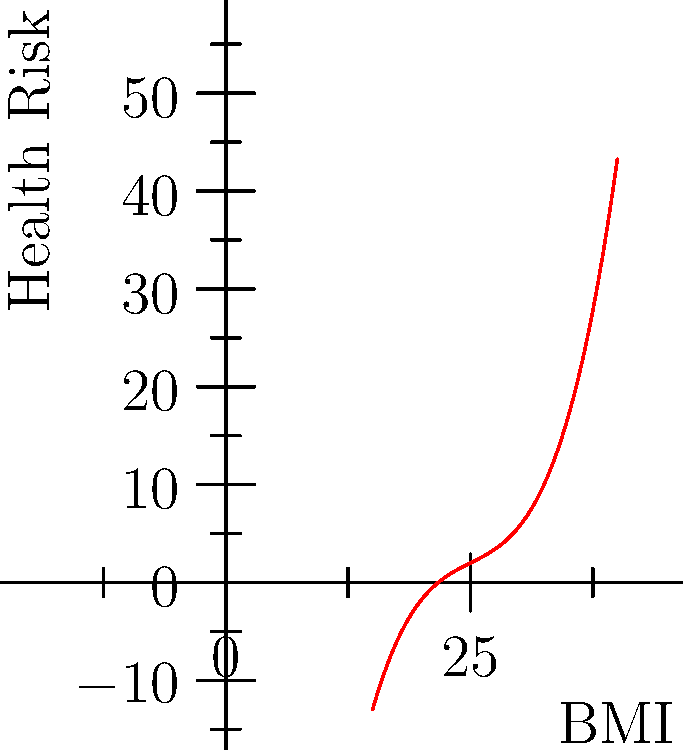The graph shows the relationship between Body Mass Index (BMI) and health risk, represented by a polynomial function. Points A, B, C, and D correspond to BMI values of 20, 25, 30, and 35, respectively. Based on this curve, which BMI range is associated with the lowest health risk, and what does this suggest about the limitations of using BMI as a sole indicator of health? To answer this question, we need to analyze the graph and interpret its implications:

1. The y-axis represents health risk, with lower values indicating lower risk.
2. The x-axis represents BMI values.
3. The curve shows how health risk changes with BMI.

Analyzing the curve:
1. The lowest point on the curve is at point B, which corresponds to a BMI of 25.
2. This indicates that a BMI of 25 is associated with the lowest health risk according to this model.
3. The curve increases on both sides of point B, showing higher health risks for both lower and higher BMI values.

Implications and limitations of BMI:
1. The U-shaped curve suggests that both underweight (BMI < 25) and overweight (BMI > 25) individuals may face increased health risks.
2. However, the curve is symmetrical around BMI 25, which doesn't accurately reflect real-world health risks. In reality, the risks associated with being underweight vs. overweight are often different.
3. The model doesn't account for factors such as muscle mass, body composition, or individual variations, which can significantly impact health regardless of BMI.
4. It doesn't consider other health indicators like blood pressure, cholesterol levels, or lifestyle factors.

In conclusion, while the graph suggests a BMI around 25 is optimal, it's crucial to recognize that BMI alone is an oversimplified measure of health. A comprehensive health assessment should include multiple factors beyond just BMI.
Answer: BMI range 23-27; BMI oversimplifies health assessment, ignoring factors like body composition and individual variations. 